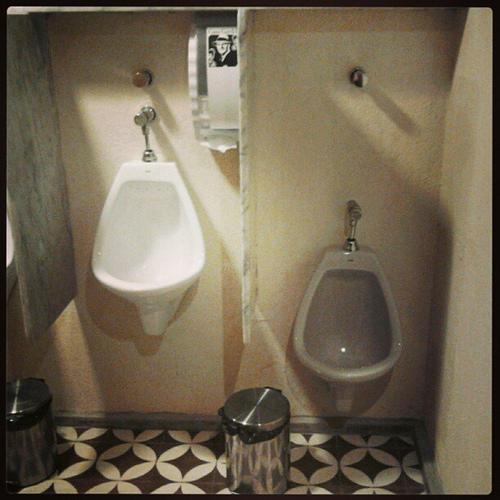How many urinals are there?
Give a very brief answer. 2. 